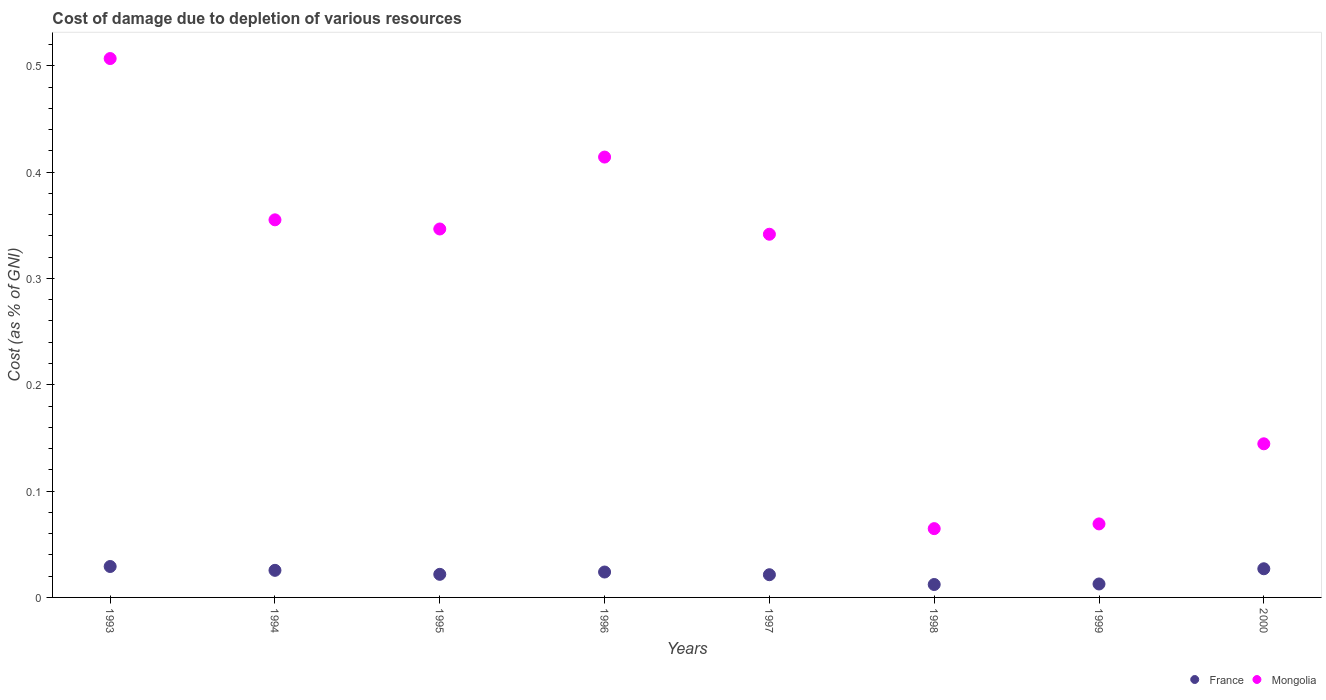Is the number of dotlines equal to the number of legend labels?
Keep it short and to the point. Yes. What is the cost of damage caused due to the depletion of various resources in Mongolia in 1995?
Provide a short and direct response. 0.35. Across all years, what is the maximum cost of damage caused due to the depletion of various resources in Mongolia?
Your response must be concise. 0.51. Across all years, what is the minimum cost of damage caused due to the depletion of various resources in Mongolia?
Provide a succinct answer. 0.06. In which year was the cost of damage caused due to the depletion of various resources in France maximum?
Ensure brevity in your answer.  1993. What is the total cost of damage caused due to the depletion of various resources in France in the graph?
Offer a terse response. 0.17. What is the difference between the cost of damage caused due to the depletion of various resources in France in 1995 and that in 1999?
Your answer should be very brief. 0.01. What is the difference between the cost of damage caused due to the depletion of various resources in France in 1993 and the cost of damage caused due to the depletion of various resources in Mongolia in 1997?
Ensure brevity in your answer.  -0.31. What is the average cost of damage caused due to the depletion of various resources in France per year?
Make the answer very short. 0.02. In the year 1993, what is the difference between the cost of damage caused due to the depletion of various resources in Mongolia and cost of damage caused due to the depletion of various resources in France?
Provide a succinct answer. 0.48. In how many years, is the cost of damage caused due to the depletion of various resources in France greater than 0.14 %?
Ensure brevity in your answer.  0. What is the ratio of the cost of damage caused due to the depletion of various resources in France in 1993 to that in 2000?
Ensure brevity in your answer.  1.08. Is the cost of damage caused due to the depletion of various resources in France in 1998 less than that in 2000?
Offer a terse response. Yes. What is the difference between the highest and the second highest cost of damage caused due to the depletion of various resources in Mongolia?
Provide a succinct answer. 0.09. What is the difference between the highest and the lowest cost of damage caused due to the depletion of various resources in Mongolia?
Ensure brevity in your answer.  0.44. Is the cost of damage caused due to the depletion of various resources in France strictly greater than the cost of damage caused due to the depletion of various resources in Mongolia over the years?
Keep it short and to the point. No. Is the cost of damage caused due to the depletion of various resources in France strictly less than the cost of damage caused due to the depletion of various resources in Mongolia over the years?
Keep it short and to the point. Yes. How many dotlines are there?
Provide a short and direct response. 2. How many years are there in the graph?
Your response must be concise. 8. Does the graph contain any zero values?
Offer a very short reply. No. How many legend labels are there?
Your answer should be very brief. 2. What is the title of the graph?
Give a very brief answer. Cost of damage due to depletion of various resources. Does "St. Lucia" appear as one of the legend labels in the graph?
Give a very brief answer. No. What is the label or title of the X-axis?
Offer a very short reply. Years. What is the label or title of the Y-axis?
Offer a very short reply. Cost (as % of GNI). What is the Cost (as % of GNI) in France in 1993?
Your answer should be compact. 0.03. What is the Cost (as % of GNI) in Mongolia in 1993?
Keep it short and to the point. 0.51. What is the Cost (as % of GNI) of France in 1994?
Offer a terse response. 0.03. What is the Cost (as % of GNI) of Mongolia in 1994?
Provide a succinct answer. 0.36. What is the Cost (as % of GNI) in France in 1995?
Provide a short and direct response. 0.02. What is the Cost (as % of GNI) of Mongolia in 1995?
Keep it short and to the point. 0.35. What is the Cost (as % of GNI) of France in 1996?
Provide a succinct answer. 0.02. What is the Cost (as % of GNI) in Mongolia in 1996?
Make the answer very short. 0.41. What is the Cost (as % of GNI) of France in 1997?
Offer a very short reply. 0.02. What is the Cost (as % of GNI) in Mongolia in 1997?
Your answer should be compact. 0.34. What is the Cost (as % of GNI) in France in 1998?
Keep it short and to the point. 0.01. What is the Cost (as % of GNI) of Mongolia in 1998?
Offer a very short reply. 0.06. What is the Cost (as % of GNI) in France in 1999?
Ensure brevity in your answer.  0.01. What is the Cost (as % of GNI) in Mongolia in 1999?
Make the answer very short. 0.07. What is the Cost (as % of GNI) of France in 2000?
Keep it short and to the point. 0.03. What is the Cost (as % of GNI) of Mongolia in 2000?
Offer a terse response. 0.14. Across all years, what is the maximum Cost (as % of GNI) in France?
Make the answer very short. 0.03. Across all years, what is the maximum Cost (as % of GNI) in Mongolia?
Give a very brief answer. 0.51. Across all years, what is the minimum Cost (as % of GNI) in France?
Your response must be concise. 0.01. Across all years, what is the minimum Cost (as % of GNI) of Mongolia?
Your answer should be compact. 0.06. What is the total Cost (as % of GNI) in France in the graph?
Your response must be concise. 0.17. What is the total Cost (as % of GNI) of Mongolia in the graph?
Offer a very short reply. 2.24. What is the difference between the Cost (as % of GNI) in France in 1993 and that in 1994?
Your answer should be very brief. 0. What is the difference between the Cost (as % of GNI) in Mongolia in 1993 and that in 1994?
Provide a succinct answer. 0.15. What is the difference between the Cost (as % of GNI) in France in 1993 and that in 1995?
Your answer should be compact. 0.01. What is the difference between the Cost (as % of GNI) of Mongolia in 1993 and that in 1995?
Provide a short and direct response. 0.16. What is the difference between the Cost (as % of GNI) of France in 1993 and that in 1996?
Offer a terse response. 0.01. What is the difference between the Cost (as % of GNI) in Mongolia in 1993 and that in 1996?
Give a very brief answer. 0.09. What is the difference between the Cost (as % of GNI) of France in 1993 and that in 1997?
Your answer should be compact. 0.01. What is the difference between the Cost (as % of GNI) in Mongolia in 1993 and that in 1997?
Your answer should be very brief. 0.17. What is the difference between the Cost (as % of GNI) of France in 1993 and that in 1998?
Ensure brevity in your answer.  0.02. What is the difference between the Cost (as % of GNI) of Mongolia in 1993 and that in 1998?
Give a very brief answer. 0.44. What is the difference between the Cost (as % of GNI) in France in 1993 and that in 1999?
Provide a succinct answer. 0.02. What is the difference between the Cost (as % of GNI) of Mongolia in 1993 and that in 1999?
Make the answer very short. 0.44. What is the difference between the Cost (as % of GNI) of France in 1993 and that in 2000?
Offer a terse response. 0. What is the difference between the Cost (as % of GNI) of Mongolia in 1993 and that in 2000?
Provide a succinct answer. 0.36. What is the difference between the Cost (as % of GNI) of France in 1994 and that in 1995?
Ensure brevity in your answer.  0. What is the difference between the Cost (as % of GNI) of Mongolia in 1994 and that in 1995?
Your response must be concise. 0.01. What is the difference between the Cost (as % of GNI) of France in 1994 and that in 1996?
Provide a short and direct response. 0. What is the difference between the Cost (as % of GNI) of Mongolia in 1994 and that in 1996?
Provide a succinct answer. -0.06. What is the difference between the Cost (as % of GNI) of France in 1994 and that in 1997?
Your answer should be very brief. 0. What is the difference between the Cost (as % of GNI) of Mongolia in 1994 and that in 1997?
Make the answer very short. 0.01. What is the difference between the Cost (as % of GNI) of France in 1994 and that in 1998?
Provide a succinct answer. 0.01. What is the difference between the Cost (as % of GNI) in Mongolia in 1994 and that in 1998?
Your response must be concise. 0.29. What is the difference between the Cost (as % of GNI) in France in 1994 and that in 1999?
Your response must be concise. 0.01. What is the difference between the Cost (as % of GNI) of Mongolia in 1994 and that in 1999?
Your response must be concise. 0.29. What is the difference between the Cost (as % of GNI) of France in 1994 and that in 2000?
Provide a short and direct response. -0. What is the difference between the Cost (as % of GNI) in Mongolia in 1994 and that in 2000?
Your answer should be compact. 0.21. What is the difference between the Cost (as % of GNI) in France in 1995 and that in 1996?
Give a very brief answer. -0. What is the difference between the Cost (as % of GNI) of Mongolia in 1995 and that in 1996?
Give a very brief answer. -0.07. What is the difference between the Cost (as % of GNI) in France in 1995 and that in 1997?
Make the answer very short. 0. What is the difference between the Cost (as % of GNI) in Mongolia in 1995 and that in 1997?
Your response must be concise. 0. What is the difference between the Cost (as % of GNI) in France in 1995 and that in 1998?
Provide a short and direct response. 0.01. What is the difference between the Cost (as % of GNI) in Mongolia in 1995 and that in 1998?
Provide a succinct answer. 0.28. What is the difference between the Cost (as % of GNI) in France in 1995 and that in 1999?
Offer a very short reply. 0.01. What is the difference between the Cost (as % of GNI) in Mongolia in 1995 and that in 1999?
Provide a succinct answer. 0.28. What is the difference between the Cost (as % of GNI) in France in 1995 and that in 2000?
Your response must be concise. -0.01. What is the difference between the Cost (as % of GNI) in Mongolia in 1995 and that in 2000?
Offer a terse response. 0.2. What is the difference between the Cost (as % of GNI) of France in 1996 and that in 1997?
Ensure brevity in your answer.  0. What is the difference between the Cost (as % of GNI) in Mongolia in 1996 and that in 1997?
Provide a short and direct response. 0.07. What is the difference between the Cost (as % of GNI) in France in 1996 and that in 1998?
Keep it short and to the point. 0.01. What is the difference between the Cost (as % of GNI) in Mongolia in 1996 and that in 1998?
Your answer should be compact. 0.35. What is the difference between the Cost (as % of GNI) in France in 1996 and that in 1999?
Give a very brief answer. 0.01. What is the difference between the Cost (as % of GNI) of Mongolia in 1996 and that in 1999?
Make the answer very short. 0.34. What is the difference between the Cost (as % of GNI) of France in 1996 and that in 2000?
Provide a succinct answer. -0. What is the difference between the Cost (as % of GNI) in Mongolia in 1996 and that in 2000?
Your answer should be very brief. 0.27. What is the difference between the Cost (as % of GNI) of France in 1997 and that in 1998?
Ensure brevity in your answer.  0.01. What is the difference between the Cost (as % of GNI) of Mongolia in 1997 and that in 1998?
Offer a terse response. 0.28. What is the difference between the Cost (as % of GNI) of France in 1997 and that in 1999?
Your answer should be compact. 0.01. What is the difference between the Cost (as % of GNI) in Mongolia in 1997 and that in 1999?
Your answer should be very brief. 0.27. What is the difference between the Cost (as % of GNI) of France in 1997 and that in 2000?
Give a very brief answer. -0.01. What is the difference between the Cost (as % of GNI) of Mongolia in 1997 and that in 2000?
Ensure brevity in your answer.  0.2. What is the difference between the Cost (as % of GNI) of France in 1998 and that in 1999?
Make the answer very short. -0. What is the difference between the Cost (as % of GNI) of Mongolia in 1998 and that in 1999?
Give a very brief answer. -0. What is the difference between the Cost (as % of GNI) of France in 1998 and that in 2000?
Offer a terse response. -0.01. What is the difference between the Cost (as % of GNI) in Mongolia in 1998 and that in 2000?
Keep it short and to the point. -0.08. What is the difference between the Cost (as % of GNI) of France in 1999 and that in 2000?
Your answer should be very brief. -0.01. What is the difference between the Cost (as % of GNI) in Mongolia in 1999 and that in 2000?
Provide a short and direct response. -0.08. What is the difference between the Cost (as % of GNI) of France in 1993 and the Cost (as % of GNI) of Mongolia in 1994?
Make the answer very short. -0.33. What is the difference between the Cost (as % of GNI) of France in 1993 and the Cost (as % of GNI) of Mongolia in 1995?
Ensure brevity in your answer.  -0.32. What is the difference between the Cost (as % of GNI) in France in 1993 and the Cost (as % of GNI) in Mongolia in 1996?
Provide a short and direct response. -0.39. What is the difference between the Cost (as % of GNI) of France in 1993 and the Cost (as % of GNI) of Mongolia in 1997?
Offer a terse response. -0.31. What is the difference between the Cost (as % of GNI) of France in 1993 and the Cost (as % of GNI) of Mongolia in 1998?
Your answer should be compact. -0.04. What is the difference between the Cost (as % of GNI) of France in 1993 and the Cost (as % of GNI) of Mongolia in 1999?
Ensure brevity in your answer.  -0.04. What is the difference between the Cost (as % of GNI) in France in 1993 and the Cost (as % of GNI) in Mongolia in 2000?
Make the answer very short. -0.12. What is the difference between the Cost (as % of GNI) in France in 1994 and the Cost (as % of GNI) in Mongolia in 1995?
Keep it short and to the point. -0.32. What is the difference between the Cost (as % of GNI) in France in 1994 and the Cost (as % of GNI) in Mongolia in 1996?
Provide a short and direct response. -0.39. What is the difference between the Cost (as % of GNI) in France in 1994 and the Cost (as % of GNI) in Mongolia in 1997?
Provide a succinct answer. -0.32. What is the difference between the Cost (as % of GNI) in France in 1994 and the Cost (as % of GNI) in Mongolia in 1998?
Your answer should be very brief. -0.04. What is the difference between the Cost (as % of GNI) of France in 1994 and the Cost (as % of GNI) of Mongolia in 1999?
Your answer should be very brief. -0.04. What is the difference between the Cost (as % of GNI) of France in 1994 and the Cost (as % of GNI) of Mongolia in 2000?
Offer a terse response. -0.12. What is the difference between the Cost (as % of GNI) of France in 1995 and the Cost (as % of GNI) of Mongolia in 1996?
Offer a terse response. -0.39. What is the difference between the Cost (as % of GNI) in France in 1995 and the Cost (as % of GNI) in Mongolia in 1997?
Offer a terse response. -0.32. What is the difference between the Cost (as % of GNI) in France in 1995 and the Cost (as % of GNI) in Mongolia in 1998?
Offer a very short reply. -0.04. What is the difference between the Cost (as % of GNI) of France in 1995 and the Cost (as % of GNI) of Mongolia in 1999?
Your answer should be very brief. -0.05. What is the difference between the Cost (as % of GNI) of France in 1995 and the Cost (as % of GNI) of Mongolia in 2000?
Keep it short and to the point. -0.12. What is the difference between the Cost (as % of GNI) of France in 1996 and the Cost (as % of GNI) of Mongolia in 1997?
Provide a short and direct response. -0.32. What is the difference between the Cost (as % of GNI) in France in 1996 and the Cost (as % of GNI) in Mongolia in 1998?
Ensure brevity in your answer.  -0.04. What is the difference between the Cost (as % of GNI) of France in 1996 and the Cost (as % of GNI) of Mongolia in 1999?
Provide a short and direct response. -0.05. What is the difference between the Cost (as % of GNI) of France in 1996 and the Cost (as % of GNI) of Mongolia in 2000?
Ensure brevity in your answer.  -0.12. What is the difference between the Cost (as % of GNI) in France in 1997 and the Cost (as % of GNI) in Mongolia in 1998?
Make the answer very short. -0.04. What is the difference between the Cost (as % of GNI) in France in 1997 and the Cost (as % of GNI) in Mongolia in 1999?
Offer a very short reply. -0.05. What is the difference between the Cost (as % of GNI) of France in 1997 and the Cost (as % of GNI) of Mongolia in 2000?
Your answer should be compact. -0.12. What is the difference between the Cost (as % of GNI) of France in 1998 and the Cost (as % of GNI) of Mongolia in 1999?
Ensure brevity in your answer.  -0.06. What is the difference between the Cost (as % of GNI) in France in 1998 and the Cost (as % of GNI) in Mongolia in 2000?
Provide a succinct answer. -0.13. What is the difference between the Cost (as % of GNI) of France in 1999 and the Cost (as % of GNI) of Mongolia in 2000?
Your response must be concise. -0.13. What is the average Cost (as % of GNI) of France per year?
Provide a succinct answer. 0.02. What is the average Cost (as % of GNI) in Mongolia per year?
Keep it short and to the point. 0.28. In the year 1993, what is the difference between the Cost (as % of GNI) in France and Cost (as % of GNI) in Mongolia?
Provide a succinct answer. -0.48. In the year 1994, what is the difference between the Cost (as % of GNI) in France and Cost (as % of GNI) in Mongolia?
Provide a short and direct response. -0.33. In the year 1995, what is the difference between the Cost (as % of GNI) in France and Cost (as % of GNI) in Mongolia?
Give a very brief answer. -0.32. In the year 1996, what is the difference between the Cost (as % of GNI) of France and Cost (as % of GNI) of Mongolia?
Offer a very short reply. -0.39. In the year 1997, what is the difference between the Cost (as % of GNI) of France and Cost (as % of GNI) of Mongolia?
Ensure brevity in your answer.  -0.32. In the year 1998, what is the difference between the Cost (as % of GNI) in France and Cost (as % of GNI) in Mongolia?
Provide a succinct answer. -0.05. In the year 1999, what is the difference between the Cost (as % of GNI) in France and Cost (as % of GNI) in Mongolia?
Provide a succinct answer. -0.06. In the year 2000, what is the difference between the Cost (as % of GNI) of France and Cost (as % of GNI) of Mongolia?
Offer a very short reply. -0.12. What is the ratio of the Cost (as % of GNI) of France in 1993 to that in 1994?
Offer a terse response. 1.14. What is the ratio of the Cost (as % of GNI) of Mongolia in 1993 to that in 1994?
Offer a very short reply. 1.43. What is the ratio of the Cost (as % of GNI) in France in 1993 to that in 1995?
Ensure brevity in your answer.  1.34. What is the ratio of the Cost (as % of GNI) in Mongolia in 1993 to that in 1995?
Keep it short and to the point. 1.46. What is the ratio of the Cost (as % of GNI) of France in 1993 to that in 1996?
Your response must be concise. 1.22. What is the ratio of the Cost (as % of GNI) in Mongolia in 1993 to that in 1996?
Make the answer very short. 1.22. What is the ratio of the Cost (as % of GNI) of France in 1993 to that in 1997?
Offer a very short reply. 1.36. What is the ratio of the Cost (as % of GNI) in Mongolia in 1993 to that in 1997?
Ensure brevity in your answer.  1.48. What is the ratio of the Cost (as % of GNI) in France in 1993 to that in 1998?
Ensure brevity in your answer.  2.39. What is the ratio of the Cost (as % of GNI) in Mongolia in 1993 to that in 1998?
Give a very brief answer. 7.83. What is the ratio of the Cost (as % of GNI) in France in 1993 to that in 1999?
Your response must be concise. 2.3. What is the ratio of the Cost (as % of GNI) in Mongolia in 1993 to that in 1999?
Offer a very short reply. 7.33. What is the ratio of the Cost (as % of GNI) of France in 1993 to that in 2000?
Provide a succinct answer. 1.08. What is the ratio of the Cost (as % of GNI) of Mongolia in 1993 to that in 2000?
Ensure brevity in your answer.  3.51. What is the ratio of the Cost (as % of GNI) of France in 1994 to that in 1995?
Your answer should be very brief. 1.17. What is the ratio of the Cost (as % of GNI) in Mongolia in 1994 to that in 1995?
Make the answer very short. 1.02. What is the ratio of the Cost (as % of GNI) of France in 1994 to that in 1996?
Make the answer very short. 1.07. What is the ratio of the Cost (as % of GNI) in Mongolia in 1994 to that in 1996?
Provide a short and direct response. 0.86. What is the ratio of the Cost (as % of GNI) in France in 1994 to that in 1997?
Give a very brief answer. 1.19. What is the ratio of the Cost (as % of GNI) of Mongolia in 1994 to that in 1997?
Make the answer very short. 1.04. What is the ratio of the Cost (as % of GNI) of France in 1994 to that in 1998?
Offer a very short reply. 2.1. What is the ratio of the Cost (as % of GNI) of Mongolia in 1994 to that in 1998?
Keep it short and to the point. 5.49. What is the ratio of the Cost (as % of GNI) of France in 1994 to that in 1999?
Give a very brief answer. 2.01. What is the ratio of the Cost (as % of GNI) of Mongolia in 1994 to that in 1999?
Give a very brief answer. 5.14. What is the ratio of the Cost (as % of GNI) in France in 1994 to that in 2000?
Provide a short and direct response. 0.95. What is the ratio of the Cost (as % of GNI) of Mongolia in 1994 to that in 2000?
Provide a succinct answer. 2.46. What is the ratio of the Cost (as % of GNI) of France in 1995 to that in 1996?
Your response must be concise. 0.91. What is the ratio of the Cost (as % of GNI) in Mongolia in 1995 to that in 1996?
Make the answer very short. 0.84. What is the ratio of the Cost (as % of GNI) of France in 1995 to that in 1997?
Keep it short and to the point. 1.02. What is the ratio of the Cost (as % of GNI) of Mongolia in 1995 to that in 1997?
Offer a terse response. 1.01. What is the ratio of the Cost (as % of GNI) in France in 1995 to that in 1998?
Provide a short and direct response. 1.79. What is the ratio of the Cost (as % of GNI) in Mongolia in 1995 to that in 1998?
Your response must be concise. 5.36. What is the ratio of the Cost (as % of GNI) of France in 1995 to that in 1999?
Offer a terse response. 1.72. What is the ratio of the Cost (as % of GNI) of Mongolia in 1995 to that in 1999?
Your answer should be very brief. 5.01. What is the ratio of the Cost (as % of GNI) of France in 1995 to that in 2000?
Provide a short and direct response. 0.81. What is the ratio of the Cost (as % of GNI) in Mongolia in 1995 to that in 2000?
Give a very brief answer. 2.4. What is the ratio of the Cost (as % of GNI) in France in 1996 to that in 1997?
Your response must be concise. 1.12. What is the ratio of the Cost (as % of GNI) of Mongolia in 1996 to that in 1997?
Your response must be concise. 1.21. What is the ratio of the Cost (as % of GNI) of France in 1996 to that in 1998?
Keep it short and to the point. 1.97. What is the ratio of the Cost (as % of GNI) of Mongolia in 1996 to that in 1998?
Your answer should be compact. 6.4. What is the ratio of the Cost (as % of GNI) in France in 1996 to that in 1999?
Ensure brevity in your answer.  1.89. What is the ratio of the Cost (as % of GNI) in Mongolia in 1996 to that in 1999?
Provide a short and direct response. 5.99. What is the ratio of the Cost (as % of GNI) in France in 1996 to that in 2000?
Provide a succinct answer. 0.89. What is the ratio of the Cost (as % of GNI) in Mongolia in 1996 to that in 2000?
Offer a terse response. 2.87. What is the ratio of the Cost (as % of GNI) in France in 1997 to that in 1998?
Provide a succinct answer. 1.76. What is the ratio of the Cost (as % of GNI) of Mongolia in 1997 to that in 1998?
Ensure brevity in your answer.  5.28. What is the ratio of the Cost (as % of GNI) in France in 1997 to that in 1999?
Keep it short and to the point. 1.69. What is the ratio of the Cost (as % of GNI) in Mongolia in 1997 to that in 1999?
Your response must be concise. 4.94. What is the ratio of the Cost (as % of GNI) in France in 1997 to that in 2000?
Your response must be concise. 0.79. What is the ratio of the Cost (as % of GNI) in Mongolia in 1997 to that in 2000?
Keep it short and to the point. 2.36. What is the ratio of the Cost (as % of GNI) of France in 1998 to that in 1999?
Keep it short and to the point. 0.96. What is the ratio of the Cost (as % of GNI) in Mongolia in 1998 to that in 1999?
Make the answer very short. 0.94. What is the ratio of the Cost (as % of GNI) of France in 1998 to that in 2000?
Give a very brief answer. 0.45. What is the ratio of the Cost (as % of GNI) in Mongolia in 1998 to that in 2000?
Give a very brief answer. 0.45. What is the ratio of the Cost (as % of GNI) in France in 1999 to that in 2000?
Your answer should be compact. 0.47. What is the ratio of the Cost (as % of GNI) of Mongolia in 1999 to that in 2000?
Provide a short and direct response. 0.48. What is the difference between the highest and the second highest Cost (as % of GNI) in France?
Ensure brevity in your answer.  0. What is the difference between the highest and the second highest Cost (as % of GNI) of Mongolia?
Provide a short and direct response. 0.09. What is the difference between the highest and the lowest Cost (as % of GNI) in France?
Give a very brief answer. 0.02. What is the difference between the highest and the lowest Cost (as % of GNI) of Mongolia?
Offer a very short reply. 0.44. 